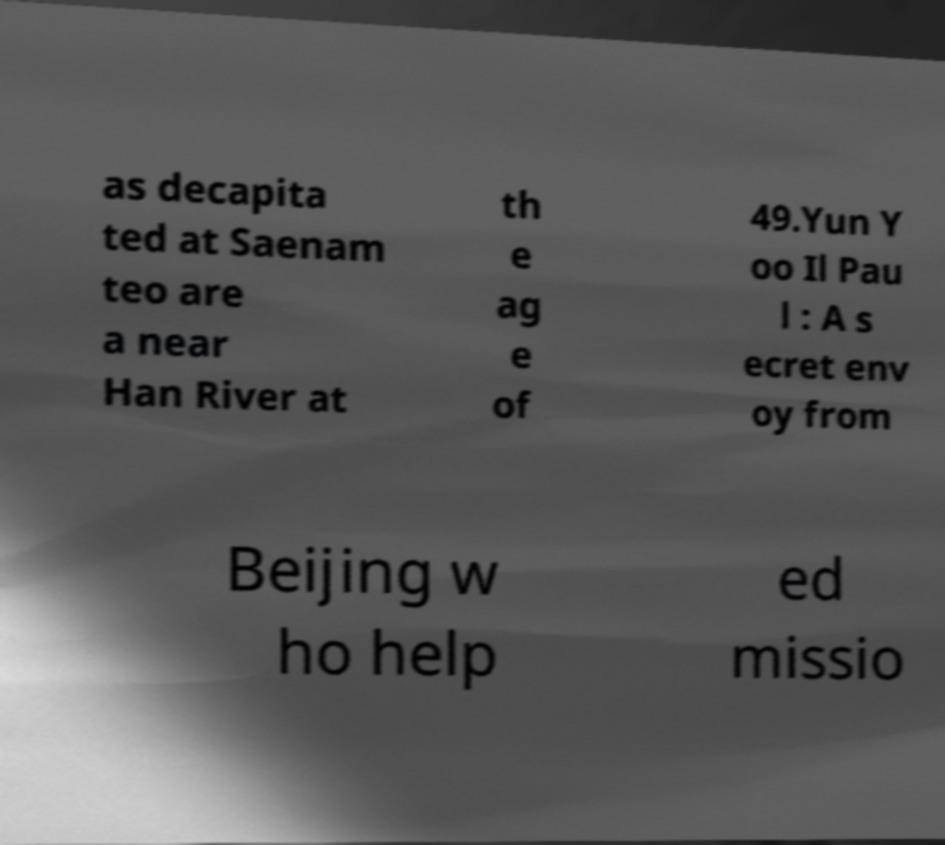For documentation purposes, I need the text within this image transcribed. Could you provide that? as decapita ted at Saenam teo are a near Han River at th e ag e of 49.Yun Y oo Il Pau l : A s ecret env oy from Beijing w ho help ed missio 